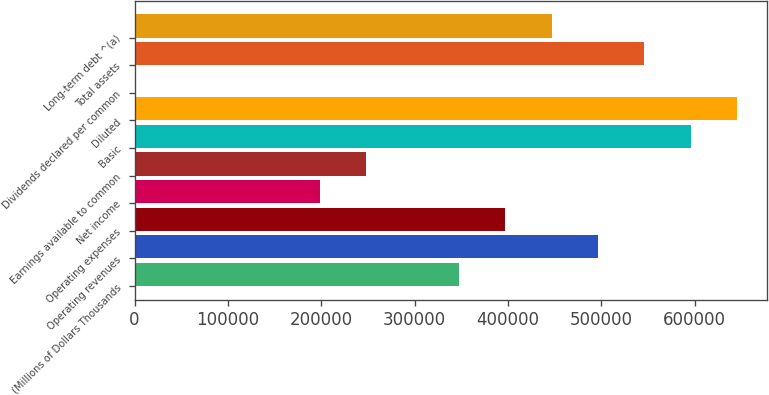<chart> <loc_0><loc_0><loc_500><loc_500><bar_chart><fcel>(Millions of Dollars Thousands<fcel>Operating revenues<fcel>Operating expenses<fcel>Net income<fcel>Earnings available to common<fcel>Basic<fcel>Diluted<fcel>Dividends declared per common<fcel>Total assets<fcel>Long-term debt ^(a)<nl><fcel>347573<fcel>496532<fcel>397226<fcel>198613<fcel>248267<fcel>595838<fcel>645491<fcel>1.11<fcel>546185<fcel>446879<nl></chart> 